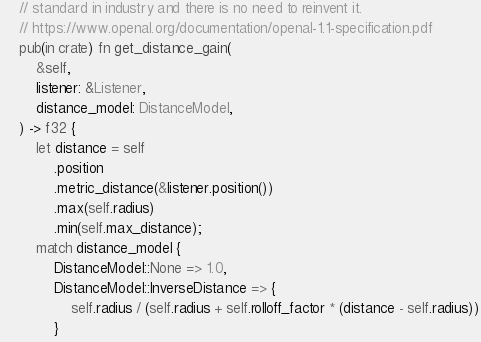<code> <loc_0><loc_0><loc_500><loc_500><_Rust_>    // standard in industry and there is no need to reinvent it.
    // https://www.openal.org/documentation/openal-1.1-specification.pdf
    pub(in crate) fn get_distance_gain(
        &self,
        listener: &Listener,
        distance_model: DistanceModel,
    ) -> f32 {
        let distance = self
            .position
            .metric_distance(&listener.position())
            .max(self.radius)
            .min(self.max_distance);
        match distance_model {
            DistanceModel::None => 1.0,
            DistanceModel::InverseDistance => {
                self.radius / (self.radius + self.rolloff_factor * (distance - self.radius))
            }</code> 